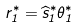<formula> <loc_0><loc_0><loc_500><loc_500>r _ { 1 } ^ { * } = \widehat { s } _ { 1 } ^ { * } \theta _ { 1 } ^ { * }</formula> 